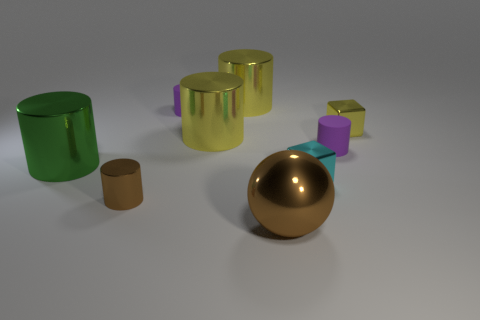Subtract all green shiny cylinders. How many cylinders are left? 5 Subtract all blocks. How many objects are left? 7 Add 1 yellow shiny cubes. How many objects exist? 10 Subtract all yellow cylinders. How many cylinders are left? 4 Subtract 0 blue balls. How many objects are left? 9 Subtract 2 cylinders. How many cylinders are left? 4 Subtract all brown cylinders. Subtract all red blocks. How many cylinders are left? 5 Subtract all green cubes. How many yellow cylinders are left? 2 Subtract all big yellow metal cubes. Subtract all tiny yellow metallic blocks. How many objects are left? 8 Add 8 small purple cylinders. How many small purple cylinders are left? 10 